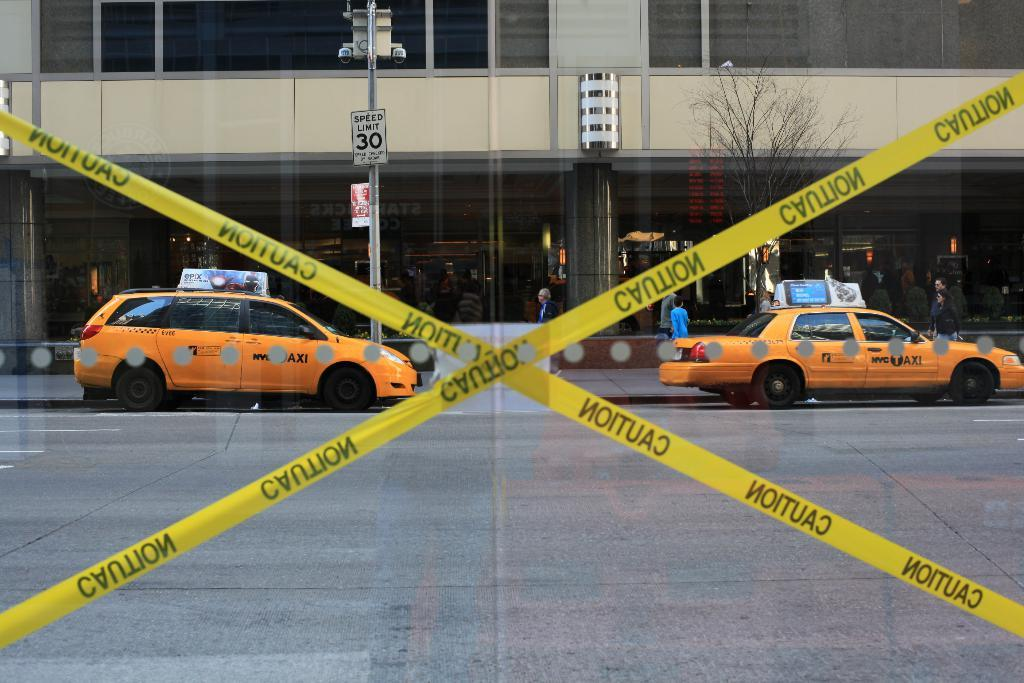<image>
Present a compact description of the photo's key features. Yellow caution tape blocks an opening on  a city street. 